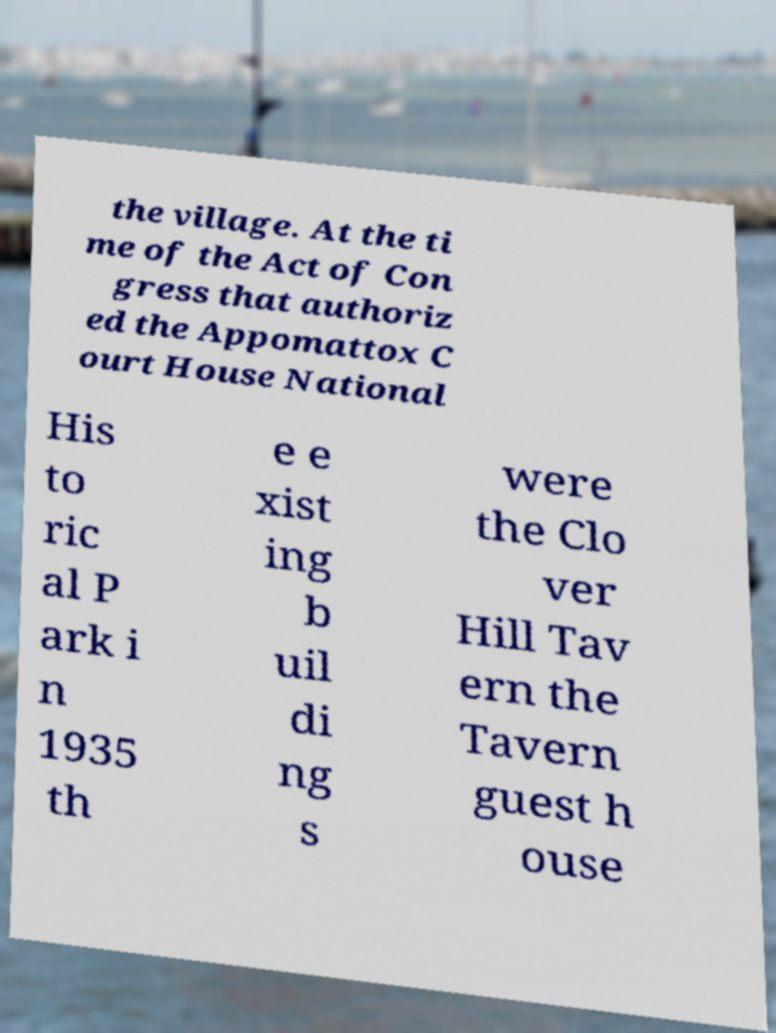For documentation purposes, I need the text within this image transcribed. Could you provide that? the village. At the ti me of the Act of Con gress that authoriz ed the Appomattox C ourt House National His to ric al P ark i n 1935 th e e xist ing b uil di ng s were the Clo ver Hill Tav ern the Tavern guest h ouse 